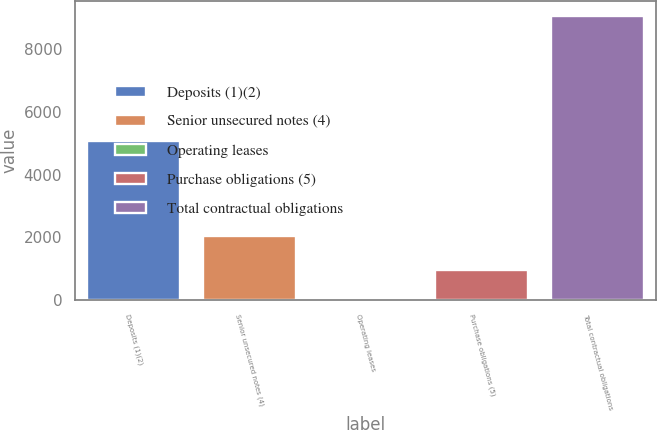Convert chart. <chart><loc_0><loc_0><loc_500><loc_500><bar_chart><fcel>Deposits (1)(2)<fcel>Senior unsecured notes (4)<fcel>Operating leases<fcel>Purchase obligations (5)<fcel>Total contractual obligations<nl><fcel>5063<fcel>2050<fcel>54<fcel>956.7<fcel>9081<nl></chart> 